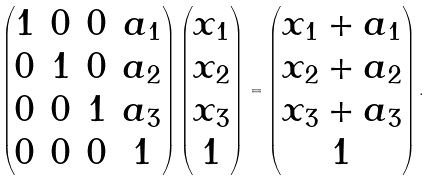Convert formula to latex. <formula><loc_0><loc_0><loc_500><loc_500>\begin{pmatrix} 1 & 0 & 0 & a _ { 1 } \\ 0 & 1 & 0 & a _ { 2 } \\ 0 & 0 & 1 & a _ { 3 } \\ 0 & 0 & 0 & 1 \end{pmatrix} \begin{pmatrix} x _ { 1 } \\ x _ { 2 } \\ x _ { 3 } \\ 1 \end{pmatrix} = \begin{pmatrix} x _ { 1 } + a _ { 1 } \\ x _ { 2 } + a _ { 2 } \\ x _ { 3 } + a _ { 3 } \\ 1 \end{pmatrix} .</formula> 